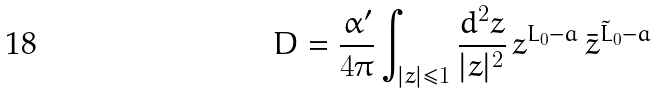Convert formula to latex. <formula><loc_0><loc_0><loc_500><loc_500>D = \frac { \alpha ^ { \prime } } { 4 \pi } \int _ { | z | \leq 1 } \frac { d ^ { 2 } z } { | z | ^ { 2 } } \, z ^ { L _ { 0 } - a } \, { \bar { z } } ^ { { \tilde { L } } _ { 0 } - a }</formula> 